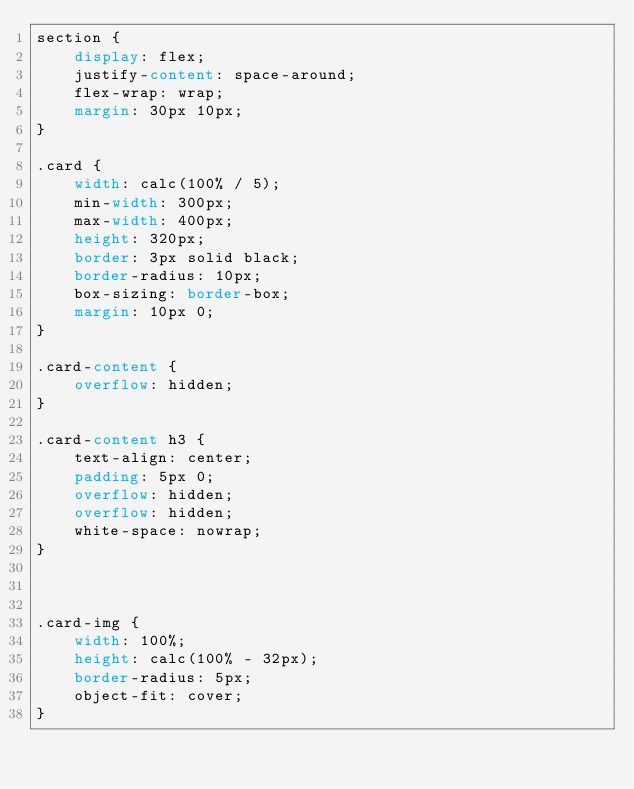<code> <loc_0><loc_0><loc_500><loc_500><_CSS_>section {
    display: flex;
    justify-content: space-around;
    flex-wrap: wrap;
    margin: 30px 10px;
}

.card {
    width: calc(100% / 5);
    min-width: 300px;
    max-width: 400px;
    height: 320px;
    border: 3px solid black;
    border-radius: 10px;
    box-sizing: border-box;
    margin: 10px 0;
}

.card-content {
    overflow: hidden;
}

.card-content h3 {
    text-align: center;
    padding: 5px 0;
    overflow: hidden;
    overflow: hidden;
    white-space: nowrap;
}



.card-img {
    width: 100%;
    height: calc(100% - 32px);
    border-radius: 5px;
    object-fit: cover;
}</code> 